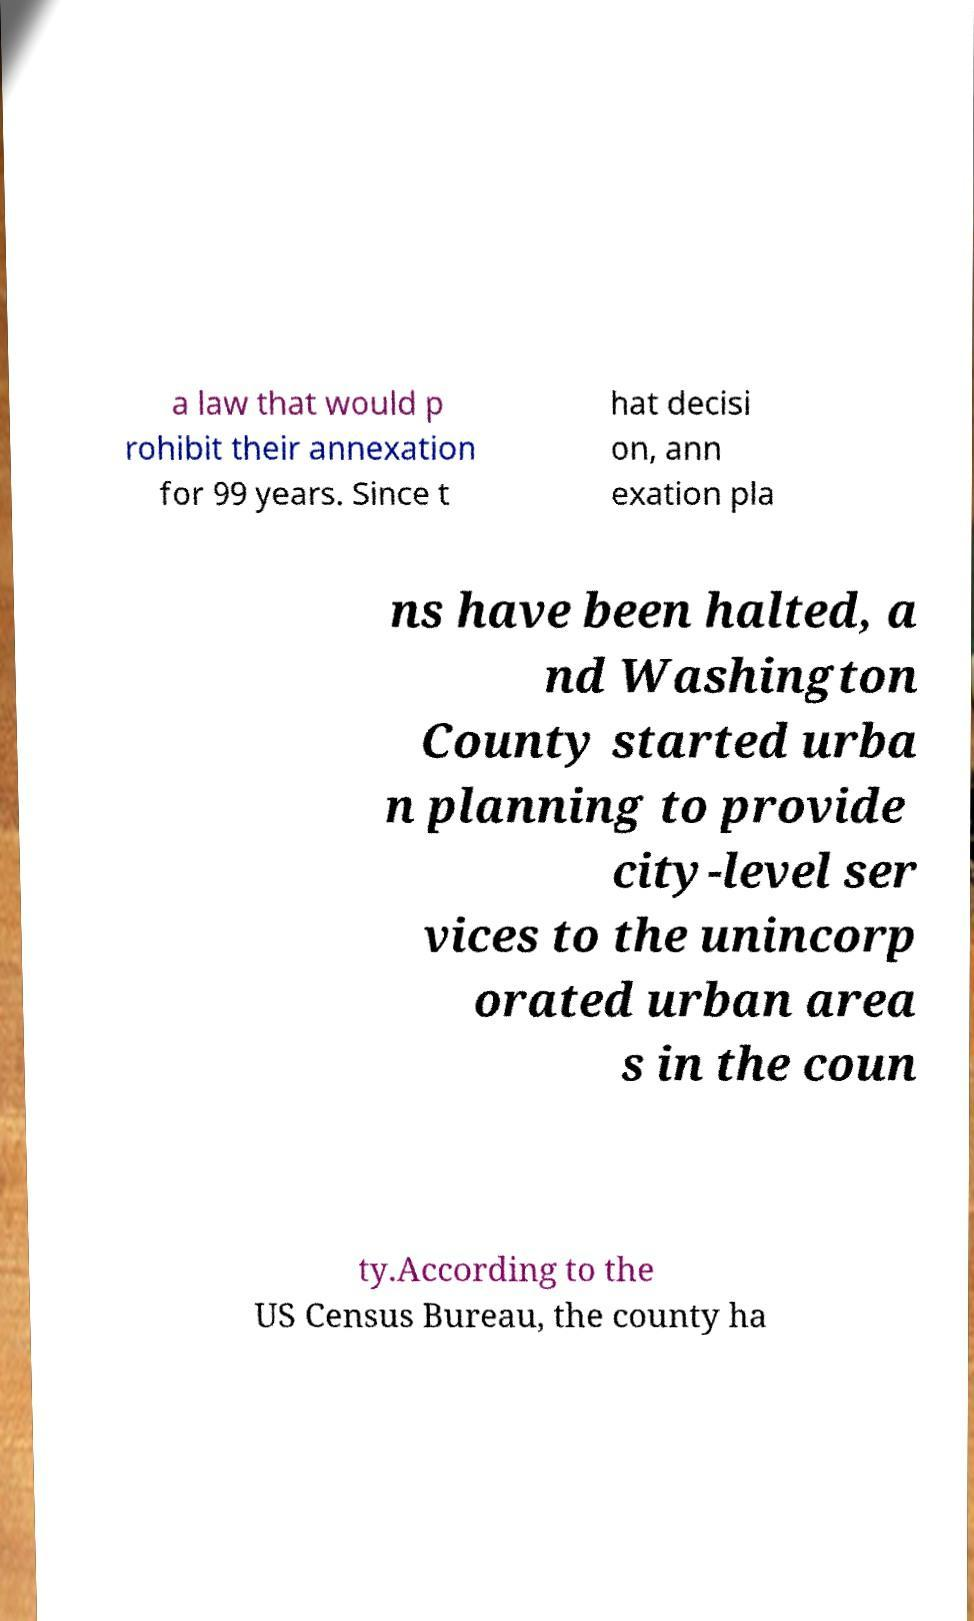For documentation purposes, I need the text within this image transcribed. Could you provide that? a law that would p rohibit their annexation for 99 years. Since t hat decisi on, ann exation pla ns have been halted, a nd Washington County started urba n planning to provide city-level ser vices to the unincorp orated urban area s in the coun ty.According to the US Census Bureau, the county ha 